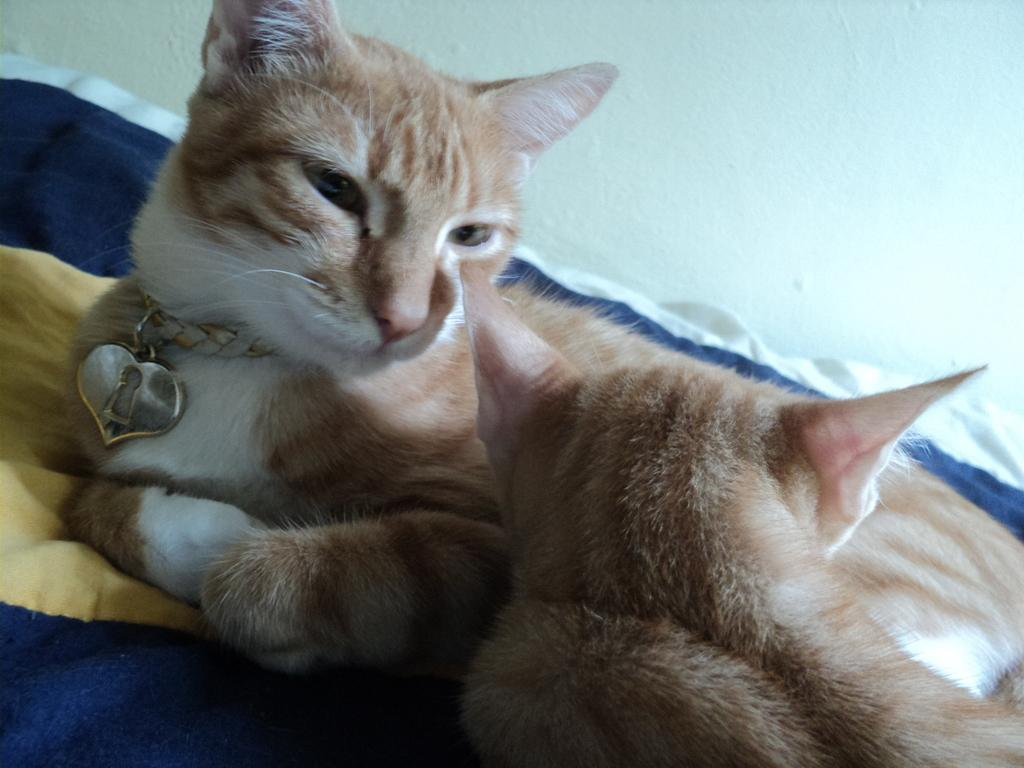How many cats are present in the image? There are two cats in the image. What color are the cats? The cats are brown in color. What are the cats sitting on? The cats are sitting on a blue cloth. What type of recess can be seen in the image? There is no recess present in the image; it features two brown cats sitting on a blue cloth. What is the plot of the cats' story in the image? There is no story or plot depicted in the image; it simply shows two cats sitting on a blue cloth. 